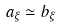<formula> <loc_0><loc_0><loc_500><loc_500>a _ { \xi } \simeq b _ { \xi }</formula> 